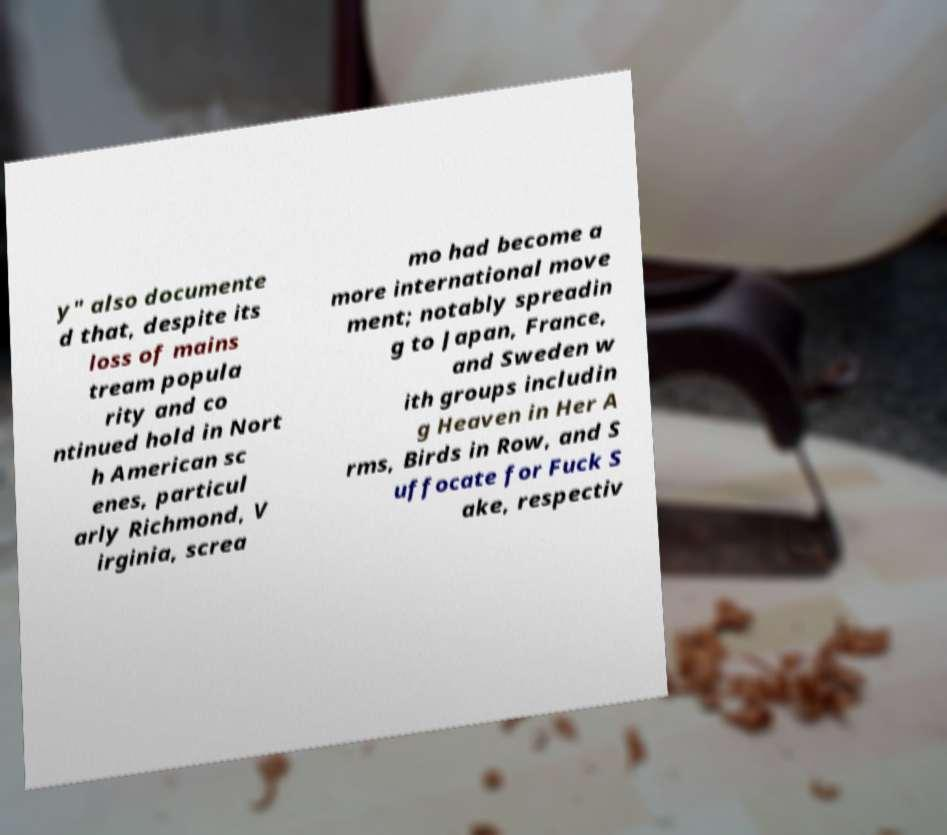Could you assist in decoding the text presented in this image and type it out clearly? y" also documente d that, despite its loss of mains tream popula rity and co ntinued hold in Nort h American sc enes, particul arly Richmond, V irginia, screa mo had become a more international move ment; notably spreadin g to Japan, France, and Sweden w ith groups includin g Heaven in Her A rms, Birds in Row, and S uffocate for Fuck S ake, respectiv 